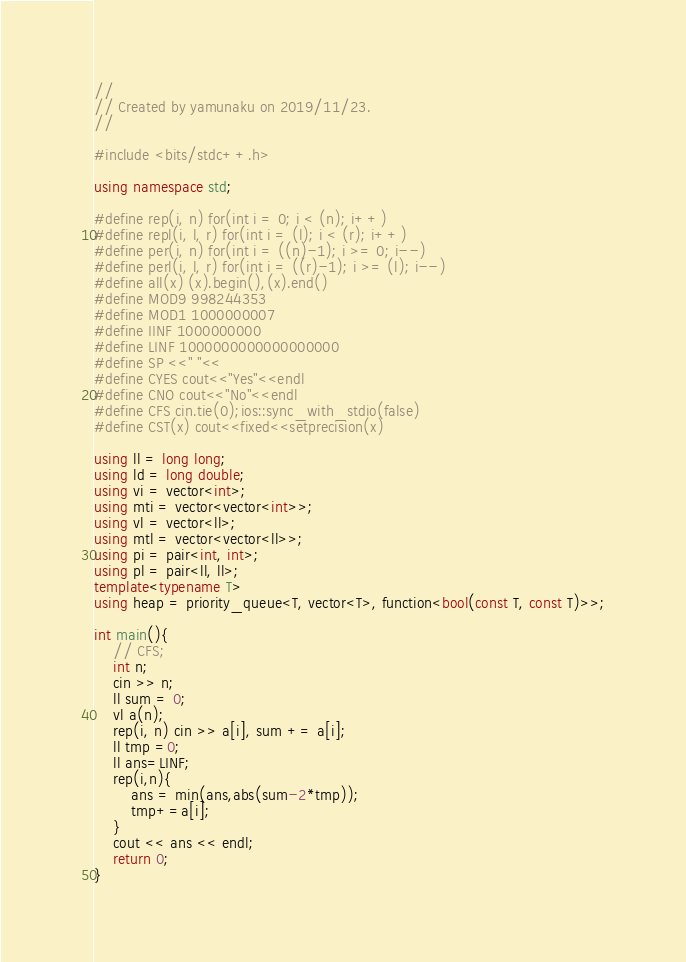<code> <loc_0><loc_0><loc_500><loc_500><_C++_>//
// Created by yamunaku on 2019/11/23.
//

#include <bits/stdc++.h>

using namespace std;

#define rep(i, n) for(int i = 0; i < (n); i++)
#define repl(i, l, r) for(int i = (l); i < (r); i++)
#define per(i, n) for(int i = ((n)-1); i >= 0; i--)
#define perl(i, l, r) for(int i = ((r)-1); i >= (l); i--)
#define all(x) (x).begin(),(x).end()
#define MOD9 998244353
#define MOD1 1000000007
#define IINF 1000000000
#define LINF 1000000000000000000
#define SP <<" "<<
#define CYES cout<<"Yes"<<endl
#define CNO cout<<"No"<<endl
#define CFS cin.tie(0);ios::sync_with_stdio(false)
#define CST(x) cout<<fixed<<setprecision(x)

using ll = long long;
using ld = long double;
using vi = vector<int>;
using mti = vector<vector<int>>;
using vl = vector<ll>;
using mtl = vector<vector<ll>>;
using pi = pair<int, int>;
using pl = pair<ll, ll>;
template<typename T>
using heap = priority_queue<T, vector<T>, function<bool(const T, const T)>>;

int main(){
    // CFS;
    int n;
    cin >> n;
    ll sum = 0;
    vl a(n);
    rep(i, n) cin >> a[i], sum += a[i];
    ll tmp =0;
    ll ans=LINF;
    rep(i,n){
        ans = min(ans,abs(sum-2*tmp));
        tmp+=a[i];
    }
    cout << ans << endl;
    return 0;
}</code> 